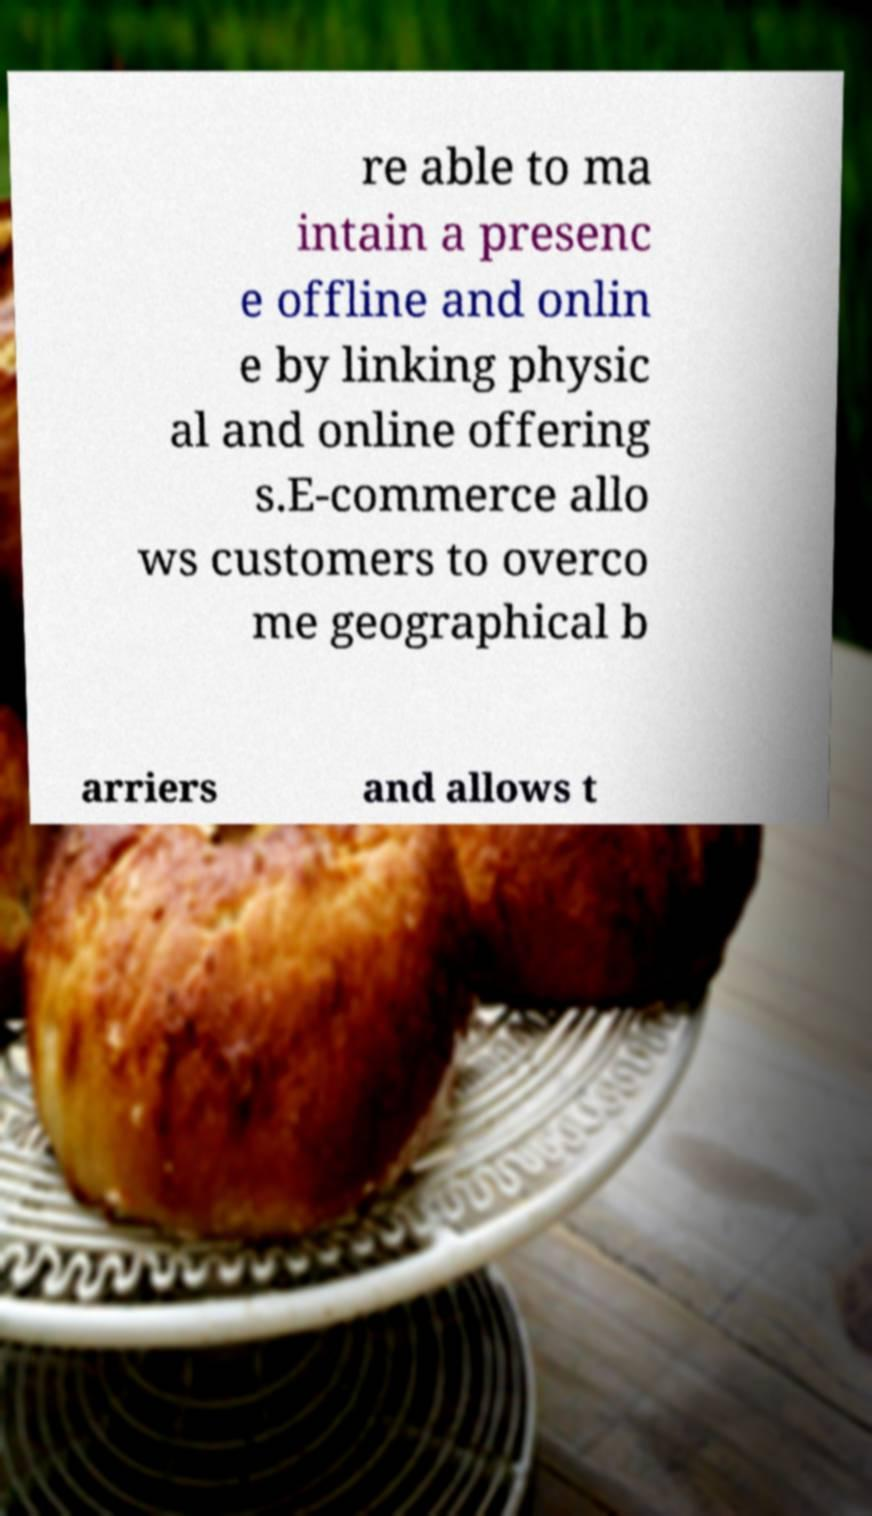What messages or text are displayed in this image? I need them in a readable, typed format. re able to ma intain a presenc e offline and onlin e by linking physic al and online offering s.E-commerce allo ws customers to overco me geographical b arriers and allows t 